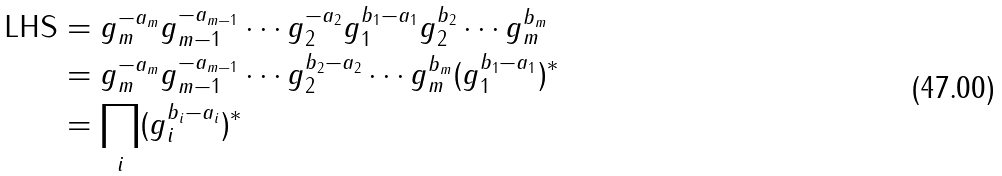<formula> <loc_0><loc_0><loc_500><loc_500>\text {LHS} & = g _ { m } ^ { - a _ { m } } g _ { m - 1 } ^ { - a _ { m - 1 } } \cdots g _ { 2 } ^ { - a _ { 2 } } g _ { 1 } ^ { b _ { 1 } - a _ { 1 } } g _ { 2 } ^ { b _ { 2 } } \cdots g _ { m } ^ { b _ { m } } \\ & = g _ { m } ^ { - a _ { m } } g _ { m - 1 } ^ { - a _ { m - 1 } } \cdots g _ { 2 } ^ { b _ { 2 } - a _ { 2 } } \cdots g _ { m } ^ { b _ { m } } ( g _ { 1 } ^ { b _ { 1 } - a _ { 1 } } ) ^ { * } \\ & = \prod _ { i } ( g _ { i } ^ { b _ { i } - a _ { i } } ) ^ { * }</formula> 